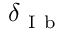Convert formula to latex. <formula><loc_0><loc_0><loc_500><loc_500>\delta _ { I b }</formula> 